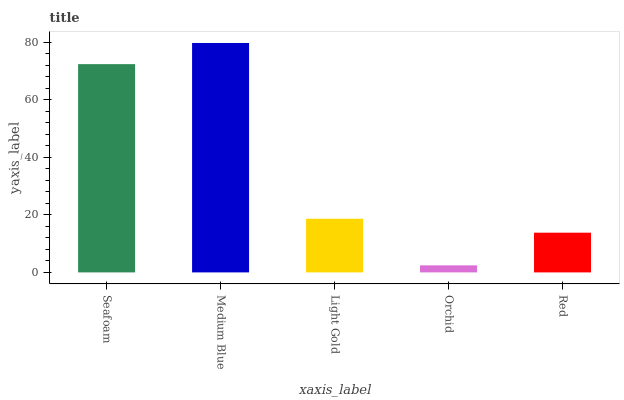Is Orchid the minimum?
Answer yes or no. Yes. Is Medium Blue the maximum?
Answer yes or no. Yes. Is Light Gold the minimum?
Answer yes or no. No. Is Light Gold the maximum?
Answer yes or no. No. Is Medium Blue greater than Light Gold?
Answer yes or no. Yes. Is Light Gold less than Medium Blue?
Answer yes or no. Yes. Is Light Gold greater than Medium Blue?
Answer yes or no. No. Is Medium Blue less than Light Gold?
Answer yes or no. No. Is Light Gold the high median?
Answer yes or no. Yes. Is Light Gold the low median?
Answer yes or no. Yes. Is Medium Blue the high median?
Answer yes or no. No. Is Medium Blue the low median?
Answer yes or no. No. 